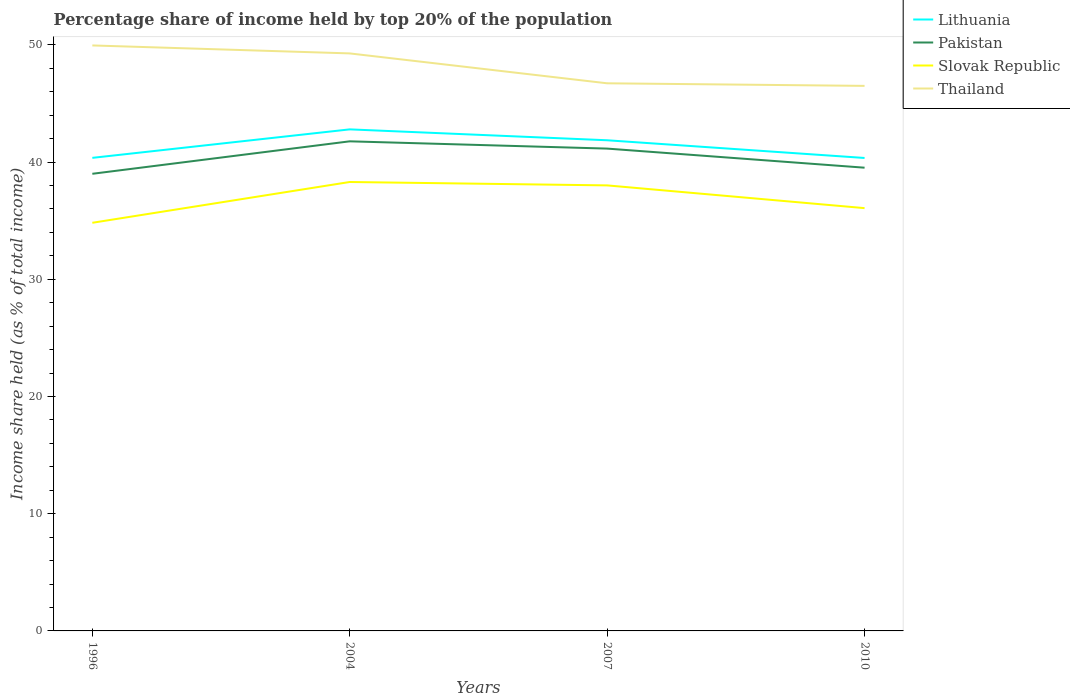How many different coloured lines are there?
Make the answer very short. 4. Does the line corresponding to Lithuania intersect with the line corresponding to Thailand?
Ensure brevity in your answer.  No. What is the total percentage share of income held by top 20% of the population in Pakistan in the graph?
Offer a terse response. -2.77. What is the difference between the highest and the second highest percentage share of income held by top 20% of the population in Thailand?
Make the answer very short. 3.45. What is the difference between the highest and the lowest percentage share of income held by top 20% of the population in Lithuania?
Provide a short and direct response. 2. How many lines are there?
Ensure brevity in your answer.  4. Does the graph contain any zero values?
Ensure brevity in your answer.  No. How are the legend labels stacked?
Provide a short and direct response. Vertical. What is the title of the graph?
Your answer should be compact. Percentage share of income held by top 20% of the population. What is the label or title of the Y-axis?
Give a very brief answer. Income share held (as % of total income). What is the Income share held (as % of total income) in Lithuania in 1996?
Make the answer very short. 40.36. What is the Income share held (as % of total income) in Slovak Republic in 1996?
Your response must be concise. 34.82. What is the Income share held (as % of total income) of Thailand in 1996?
Provide a succinct answer. 49.95. What is the Income share held (as % of total income) of Lithuania in 2004?
Provide a succinct answer. 42.79. What is the Income share held (as % of total income) in Pakistan in 2004?
Your response must be concise. 41.77. What is the Income share held (as % of total income) of Slovak Republic in 2004?
Provide a short and direct response. 38.3. What is the Income share held (as % of total income) of Thailand in 2004?
Make the answer very short. 49.27. What is the Income share held (as % of total income) of Lithuania in 2007?
Ensure brevity in your answer.  41.86. What is the Income share held (as % of total income) of Pakistan in 2007?
Provide a succinct answer. 41.15. What is the Income share held (as % of total income) in Slovak Republic in 2007?
Provide a short and direct response. 38.01. What is the Income share held (as % of total income) of Thailand in 2007?
Offer a terse response. 46.72. What is the Income share held (as % of total income) in Lithuania in 2010?
Provide a succinct answer. 40.35. What is the Income share held (as % of total income) in Pakistan in 2010?
Offer a terse response. 39.52. What is the Income share held (as % of total income) of Slovak Republic in 2010?
Ensure brevity in your answer.  36.07. What is the Income share held (as % of total income) in Thailand in 2010?
Your answer should be very brief. 46.5. Across all years, what is the maximum Income share held (as % of total income) of Lithuania?
Your answer should be compact. 42.79. Across all years, what is the maximum Income share held (as % of total income) in Pakistan?
Ensure brevity in your answer.  41.77. Across all years, what is the maximum Income share held (as % of total income) in Slovak Republic?
Ensure brevity in your answer.  38.3. Across all years, what is the maximum Income share held (as % of total income) in Thailand?
Your answer should be very brief. 49.95. Across all years, what is the minimum Income share held (as % of total income) in Lithuania?
Your answer should be very brief. 40.35. Across all years, what is the minimum Income share held (as % of total income) in Pakistan?
Provide a short and direct response. 39. Across all years, what is the minimum Income share held (as % of total income) in Slovak Republic?
Your answer should be compact. 34.82. Across all years, what is the minimum Income share held (as % of total income) of Thailand?
Your answer should be compact. 46.5. What is the total Income share held (as % of total income) of Lithuania in the graph?
Offer a terse response. 165.36. What is the total Income share held (as % of total income) of Pakistan in the graph?
Offer a very short reply. 161.44. What is the total Income share held (as % of total income) of Slovak Republic in the graph?
Ensure brevity in your answer.  147.2. What is the total Income share held (as % of total income) in Thailand in the graph?
Provide a succinct answer. 192.44. What is the difference between the Income share held (as % of total income) in Lithuania in 1996 and that in 2004?
Your answer should be compact. -2.43. What is the difference between the Income share held (as % of total income) in Pakistan in 1996 and that in 2004?
Your response must be concise. -2.77. What is the difference between the Income share held (as % of total income) of Slovak Republic in 1996 and that in 2004?
Give a very brief answer. -3.48. What is the difference between the Income share held (as % of total income) of Thailand in 1996 and that in 2004?
Ensure brevity in your answer.  0.68. What is the difference between the Income share held (as % of total income) of Lithuania in 1996 and that in 2007?
Your answer should be very brief. -1.5. What is the difference between the Income share held (as % of total income) of Pakistan in 1996 and that in 2007?
Provide a succinct answer. -2.15. What is the difference between the Income share held (as % of total income) in Slovak Republic in 1996 and that in 2007?
Ensure brevity in your answer.  -3.19. What is the difference between the Income share held (as % of total income) in Thailand in 1996 and that in 2007?
Offer a terse response. 3.23. What is the difference between the Income share held (as % of total income) of Lithuania in 1996 and that in 2010?
Keep it short and to the point. 0.01. What is the difference between the Income share held (as % of total income) of Pakistan in 1996 and that in 2010?
Offer a terse response. -0.52. What is the difference between the Income share held (as % of total income) of Slovak Republic in 1996 and that in 2010?
Ensure brevity in your answer.  -1.25. What is the difference between the Income share held (as % of total income) in Thailand in 1996 and that in 2010?
Your answer should be very brief. 3.45. What is the difference between the Income share held (as % of total income) of Lithuania in 2004 and that in 2007?
Your answer should be very brief. 0.93. What is the difference between the Income share held (as % of total income) of Pakistan in 2004 and that in 2007?
Your answer should be very brief. 0.62. What is the difference between the Income share held (as % of total income) in Slovak Republic in 2004 and that in 2007?
Give a very brief answer. 0.29. What is the difference between the Income share held (as % of total income) in Thailand in 2004 and that in 2007?
Provide a short and direct response. 2.55. What is the difference between the Income share held (as % of total income) in Lithuania in 2004 and that in 2010?
Provide a succinct answer. 2.44. What is the difference between the Income share held (as % of total income) of Pakistan in 2004 and that in 2010?
Provide a succinct answer. 2.25. What is the difference between the Income share held (as % of total income) of Slovak Republic in 2004 and that in 2010?
Your answer should be compact. 2.23. What is the difference between the Income share held (as % of total income) in Thailand in 2004 and that in 2010?
Offer a very short reply. 2.77. What is the difference between the Income share held (as % of total income) of Lithuania in 2007 and that in 2010?
Your answer should be very brief. 1.51. What is the difference between the Income share held (as % of total income) of Pakistan in 2007 and that in 2010?
Provide a succinct answer. 1.63. What is the difference between the Income share held (as % of total income) in Slovak Republic in 2007 and that in 2010?
Your answer should be very brief. 1.94. What is the difference between the Income share held (as % of total income) of Thailand in 2007 and that in 2010?
Ensure brevity in your answer.  0.22. What is the difference between the Income share held (as % of total income) in Lithuania in 1996 and the Income share held (as % of total income) in Pakistan in 2004?
Offer a terse response. -1.41. What is the difference between the Income share held (as % of total income) in Lithuania in 1996 and the Income share held (as % of total income) in Slovak Republic in 2004?
Your response must be concise. 2.06. What is the difference between the Income share held (as % of total income) in Lithuania in 1996 and the Income share held (as % of total income) in Thailand in 2004?
Provide a succinct answer. -8.91. What is the difference between the Income share held (as % of total income) in Pakistan in 1996 and the Income share held (as % of total income) in Thailand in 2004?
Your answer should be very brief. -10.27. What is the difference between the Income share held (as % of total income) in Slovak Republic in 1996 and the Income share held (as % of total income) in Thailand in 2004?
Make the answer very short. -14.45. What is the difference between the Income share held (as % of total income) of Lithuania in 1996 and the Income share held (as % of total income) of Pakistan in 2007?
Keep it short and to the point. -0.79. What is the difference between the Income share held (as % of total income) in Lithuania in 1996 and the Income share held (as % of total income) in Slovak Republic in 2007?
Provide a succinct answer. 2.35. What is the difference between the Income share held (as % of total income) in Lithuania in 1996 and the Income share held (as % of total income) in Thailand in 2007?
Offer a very short reply. -6.36. What is the difference between the Income share held (as % of total income) in Pakistan in 1996 and the Income share held (as % of total income) in Thailand in 2007?
Give a very brief answer. -7.72. What is the difference between the Income share held (as % of total income) in Slovak Republic in 1996 and the Income share held (as % of total income) in Thailand in 2007?
Offer a very short reply. -11.9. What is the difference between the Income share held (as % of total income) of Lithuania in 1996 and the Income share held (as % of total income) of Pakistan in 2010?
Offer a terse response. 0.84. What is the difference between the Income share held (as % of total income) in Lithuania in 1996 and the Income share held (as % of total income) in Slovak Republic in 2010?
Give a very brief answer. 4.29. What is the difference between the Income share held (as % of total income) in Lithuania in 1996 and the Income share held (as % of total income) in Thailand in 2010?
Your answer should be compact. -6.14. What is the difference between the Income share held (as % of total income) of Pakistan in 1996 and the Income share held (as % of total income) of Slovak Republic in 2010?
Your response must be concise. 2.93. What is the difference between the Income share held (as % of total income) in Slovak Republic in 1996 and the Income share held (as % of total income) in Thailand in 2010?
Your response must be concise. -11.68. What is the difference between the Income share held (as % of total income) of Lithuania in 2004 and the Income share held (as % of total income) of Pakistan in 2007?
Ensure brevity in your answer.  1.64. What is the difference between the Income share held (as % of total income) of Lithuania in 2004 and the Income share held (as % of total income) of Slovak Republic in 2007?
Your response must be concise. 4.78. What is the difference between the Income share held (as % of total income) of Lithuania in 2004 and the Income share held (as % of total income) of Thailand in 2007?
Ensure brevity in your answer.  -3.93. What is the difference between the Income share held (as % of total income) of Pakistan in 2004 and the Income share held (as % of total income) of Slovak Republic in 2007?
Offer a very short reply. 3.76. What is the difference between the Income share held (as % of total income) of Pakistan in 2004 and the Income share held (as % of total income) of Thailand in 2007?
Offer a terse response. -4.95. What is the difference between the Income share held (as % of total income) in Slovak Republic in 2004 and the Income share held (as % of total income) in Thailand in 2007?
Keep it short and to the point. -8.42. What is the difference between the Income share held (as % of total income) of Lithuania in 2004 and the Income share held (as % of total income) of Pakistan in 2010?
Give a very brief answer. 3.27. What is the difference between the Income share held (as % of total income) in Lithuania in 2004 and the Income share held (as % of total income) in Slovak Republic in 2010?
Ensure brevity in your answer.  6.72. What is the difference between the Income share held (as % of total income) in Lithuania in 2004 and the Income share held (as % of total income) in Thailand in 2010?
Your answer should be very brief. -3.71. What is the difference between the Income share held (as % of total income) in Pakistan in 2004 and the Income share held (as % of total income) in Slovak Republic in 2010?
Your answer should be very brief. 5.7. What is the difference between the Income share held (as % of total income) in Pakistan in 2004 and the Income share held (as % of total income) in Thailand in 2010?
Your response must be concise. -4.73. What is the difference between the Income share held (as % of total income) of Slovak Republic in 2004 and the Income share held (as % of total income) of Thailand in 2010?
Provide a short and direct response. -8.2. What is the difference between the Income share held (as % of total income) of Lithuania in 2007 and the Income share held (as % of total income) of Pakistan in 2010?
Make the answer very short. 2.34. What is the difference between the Income share held (as % of total income) of Lithuania in 2007 and the Income share held (as % of total income) of Slovak Republic in 2010?
Your response must be concise. 5.79. What is the difference between the Income share held (as % of total income) in Lithuania in 2007 and the Income share held (as % of total income) in Thailand in 2010?
Offer a terse response. -4.64. What is the difference between the Income share held (as % of total income) in Pakistan in 2007 and the Income share held (as % of total income) in Slovak Republic in 2010?
Offer a terse response. 5.08. What is the difference between the Income share held (as % of total income) in Pakistan in 2007 and the Income share held (as % of total income) in Thailand in 2010?
Your response must be concise. -5.35. What is the difference between the Income share held (as % of total income) in Slovak Republic in 2007 and the Income share held (as % of total income) in Thailand in 2010?
Make the answer very short. -8.49. What is the average Income share held (as % of total income) of Lithuania per year?
Provide a succinct answer. 41.34. What is the average Income share held (as % of total income) in Pakistan per year?
Make the answer very short. 40.36. What is the average Income share held (as % of total income) of Slovak Republic per year?
Your response must be concise. 36.8. What is the average Income share held (as % of total income) of Thailand per year?
Make the answer very short. 48.11. In the year 1996, what is the difference between the Income share held (as % of total income) of Lithuania and Income share held (as % of total income) of Pakistan?
Your answer should be compact. 1.36. In the year 1996, what is the difference between the Income share held (as % of total income) of Lithuania and Income share held (as % of total income) of Slovak Republic?
Your answer should be very brief. 5.54. In the year 1996, what is the difference between the Income share held (as % of total income) in Lithuania and Income share held (as % of total income) in Thailand?
Keep it short and to the point. -9.59. In the year 1996, what is the difference between the Income share held (as % of total income) in Pakistan and Income share held (as % of total income) in Slovak Republic?
Make the answer very short. 4.18. In the year 1996, what is the difference between the Income share held (as % of total income) in Pakistan and Income share held (as % of total income) in Thailand?
Your response must be concise. -10.95. In the year 1996, what is the difference between the Income share held (as % of total income) of Slovak Republic and Income share held (as % of total income) of Thailand?
Give a very brief answer. -15.13. In the year 2004, what is the difference between the Income share held (as % of total income) in Lithuania and Income share held (as % of total income) in Slovak Republic?
Offer a terse response. 4.49. In the year 2004, what is the difference between the Income share held (as % of total income) in Lithuania and Income share held (as % of total income) in Thailand?
Provide a succinct answer. -6.48. In the year 2004, what is the difference between the Income share held (as % of total income) in Pakistan and Income share held (as % of total income) in Slovak Republic?
Your answer should be compact. 3.47. In the year 2004, what is the difference between the Income share held (as % of total income) in Pakistan and Income share held (as % of total income) in Thailand?
Provide a succinct answer. -7.5. In the year 2004, what is the difference between the Income share held (as % of total income) in Slovak Republic and Income share held (as % of total income) in Thailand?
Keep it short and to the point. -10.97. In the year 2007, what is the difference between the Income share held (as % of total income) of Lithuania and Income share held (as % of total income) of Pakistan?
Give a very brief answer. 0.71. In the year 2007, what is the difference between the Income share held (as % of total income) of Lithuania and Income share held (as % of total income) of Slovak Republic?
Offer a terse response. 3.85. In the year 2007, what is the difference between the Income share held (as % of total income) in Lithuania and Income share held (as % of total income) in Thailand?
Your answer should be very brief. -4.86. In the year 2007, what is the difference between the Income share held (as % of total income) of Pakistan and Income share held (as % of total income) of Slovak Republic?
Your answer should be very brief. 3.14. In the year 2007, what is the difference between the Income share held (as % of total income) of Pakistan and Income share held (as % of total income) of Thailand?
Ensure brevity in your answer.  -5.57. In the year 2007, what is the difference between the Income share held (as % of total income) in Slovak Republic and Income share held (as % of total income) in Thailand?
Provide a short and direct response. -8.71. In the year 2010, what is the difference between the Income share held (as % of total income) of Lithuania and Income share held (as % of total income) of Pakistan?
Your answer should be compact. 0.83. In the year 2010, what is the difference between the Income share held (as % of total income) in Lithuania and Income share held (as % of total income) in Slovak Republic?
Your response must be concise. 4.28. In the year 2010, what is the difference between the Income share held (as % of total income) of Lithuania and Income share held (as % of total income) of Thailand?
Your response must be concise. -6.15. In the year 2010, what is the difference between the Income share held (as % of total income) of Pakistan and Income share held (as % of total income) of Slovak Republic?
Offer a very short reply. 3.45. In the year 2010, what is the difference between the Income share held (as % of total income) of Pakistan and Income share held (as % of total income) of Thailand?
Ensure brevity in your answer.  -6.98. In the year 2010, what is the difference between the Income share held (as % of total income) of Slovak Republic and Income share held (as % of total income) of Thailand?
Your answer should be compact. -10.43. What is the ratio of the Income share held (as % of total income) in Lithuania in 1996 to that in 2004?
Your answer should be very brief. 0.94. What is the ratio of the Income share held (as % of total income) in Pakistan in 1996 to that in 2004?
Your response must be concise. 0.93. What is the ratio of the Income share held (as % of total income) of Thailand in 1996 to that in 2004?
Provide a short and direct response. 1.01. What is the ratio of the Income share held (as % of total income) in Lithuania in 1996 to that in 2007?
Offer a very short reply. 0.96. What is the ratio of the Income share held (as % of total income) of Pakistan in 1996 to that in 2007?
Ensure brevity in your answer.  0.95. What is the ratio of the Income share held (as % of total income) in Slovak Republic in 1996 to that in 2007?
Your answer should be very brief. 0.92. What is the ratio of the Income share held (as % of total income) of Thailand in 1996 to that in 2007?
Your answer should be compact. 1.07. What is the ratio of the Income share held (as % of total income) of Lithuania in 1996 to that in 2010?
Make the answer very short. 1. What is the ratio of the Income share held (as % of total income) in Pakistan in 1996 to that in 2010?
Your answer should be compact. 0.99. What is the ratio of the Income share held (as % of total income) of Slovak Republic in 1996 to that in 2010?
Make the answer very short. 0.97. What is the ratio of the Income share held (as % of total income) in Thailand in 1996 to that in 2010?
Give a very brief answer. 1.07. What is the ratio of the Income share held (as % of total income) in Lithuania in 2004 to that in 2007?
Ensure brevity in your answer.  1.02. What is the ratio of the Income share held (as % of total income) in Pakistan in 2004 to that in 2007?
Offer a terse response. 1.02. What is the ratio of the Income share held (as % of total income) of Slovak Republic in 2004 to that in 2007?
Ensure brevity in your answer.  1.01. What is the ratio of the Income share held (as % of total income) in Thailand in 2004 to that in 2007?
Provide a succinct answer. 1.05. What is the ratio of the Income share held (as % of total income) of Lithuania in 2004 to that in 2010?
Give a very brief answer. 1.06. What is the ratio of the Income share held (as % of total income) in Pakistan in 2004 to that in 2010?
Offer a very short reply. 1.06. What is the ratio of the Income share held (as % of total income) of Slovak Republic in 2004 to that in 2010?
Provide a succinct answer. 1.06. What is the ratio of the Income share held (as % of total income) in Thailand in 2004 to that in 2010?
Keep it short and to the point. 1.06. What is the ratio of the Income share held (as % of total income) in Lithuania in 2007 to that in 2010?
Your answer should be very brief. 1.04. What is the ratio of the Income share held (as % of total income) in Pakistan in 2007 to that in 2010?
Offer a terse response. 1.04. What is the ratio of the Income share held (as % of total income) in Slovak Republic in 2007 to that in 2010?
Keep it short and to the point. 1.05. What is the ratio of the Income share held (as % of total income) of Thailand in 2007 to that in 2010?
Offer a terse response. 1. What is the difference between the highest and the second highest Income share held (as % of total income) in Lithuania?
Ensure brevity in your answer.  0.93. What is the difference between the highest and the second highest Income share held (as % of total income) of Pakistan?
Provide a succinct answer. 0.62. What is the difference between the highest and the second highest Income share held (as % of total income) of Slovak Republic?
Give a very brief answer. 0.29. What is the difference between the highest and the second highest Income share held (as % of total income) in Thailand?
Give a very brief answer. 0.68. What is the difference between the highest and the lowest Income share held (as % of total income) of Lithuania?
Provide a short and direct response. 2.44. What is the difference between the highest and the lowest Income share held (as % of total income) in Pakistan?
Ensure brevity in your answer.  2.77. What is the difference between the highest and the lowest Income share held (as % of total income) of Slovak Republic?
Offer a very short reply. 3.48. What is the difference between the highest and the lowest Income share held (as % of total income) in Thailand?
Provide a short and direct response. 3.45. 